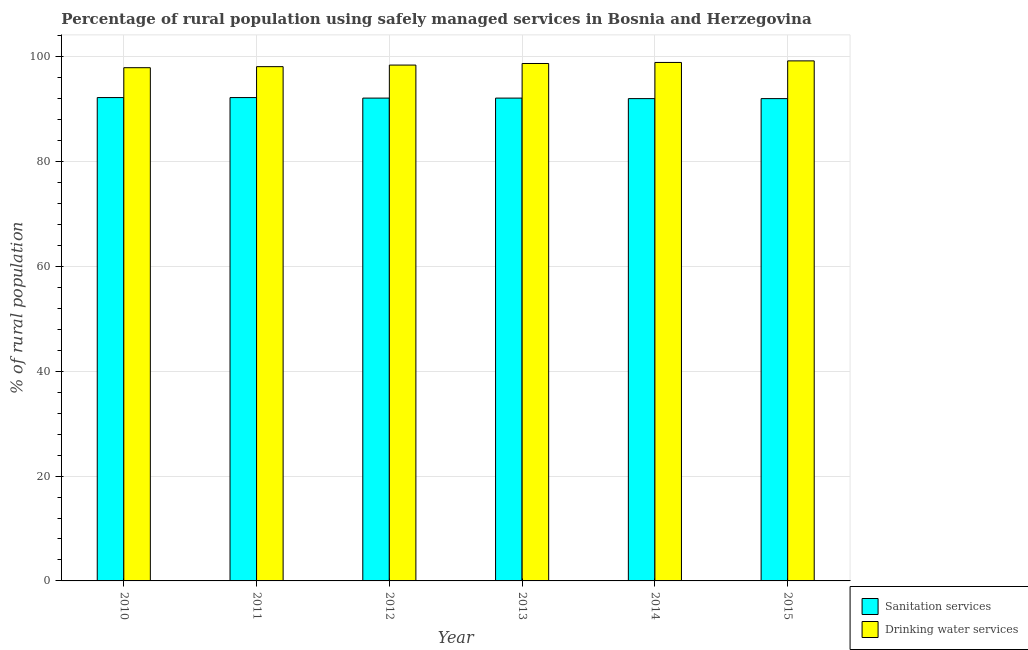How many different coloured bars are there?
Offer a very short reply. 2. How many groups of bars are there?
Offer a very short reply. 6. Are the number of bars per tick equal to the number of legend labels?
Ensure brevity in your answer.  Yes. Are the number of bars on each tick of the X-axis equal?
Your answer should be compact. Yes. How many bars are there on the 5th tick from the left?
Offer a very short reply. 2. How many bars are there on the 2nd tick from the right?
Keep it short and to the point. 2. What is the label of the 5th group of bars from the left?
Provide a short and direct response. 2014. In how many cases, is the number of bars for a given year not equal to the number of legend labels?
Offer a terse response. 0. What is the percentage of rural population who used drinking water services in 2012?
Offer a terse response. 98.4. Across all years, what is the maximum percentage of rural population who used sanitation services?
Ensure brevity in your answer.  92.2. Across all years, what is the minimum percentage of rural population who used sanitation services?
Provide a succinct answer. 92. What is the total percentage of rural population who used sanitation services in the graph?
Give a very brief answer. 552.6. What is the difference between the percentage of rural population who used sanitation services in 2011 and that in 2015?
Offer a terse response. 0.2. What is the difference between the percentage of rural population who used drinking water services in 2012 and the percentage of rural population who used sanitation services in 2011?
Your answer should be compact. 0.3. What is the average percentage of rural population who used drinking water services per year?
Make the answer very short. 98.53. In the year 2014, what is the difference between the percentage of rural population who used sanitation services and percentage of rural population who used drinking water services?
Your answer should be compact. 0. In how many years, is the percentage of rural population who used sanitation services greater than 28 %?
Give a very brief answer. 6. What is the ratio of the percentage of rural population who used sanitation services in 2011 to that in 2013?
Provide a short and direct response. 1. Is the percentage of rural population who used sanitation services in 2012 less than that in 2013?
Your response must be concise. No. What is the difference between the highest and the second highest percentage of rural population who used drinking water services?
Offer a very short reply. 0.3. What is the difference between the highest and the lowest percentage of rural population who used sanitation services?
Keep it short and to the point. 0.2. What does the 2nd bar from the left in 2014 represents?
Your response must be concise. Drinking water services. What does the 2nd bar from the right in 2013 represents?
Your answer should be very brief. Sanitation services. How many bars are there?
Your response must be concise. 12. How many years are there in the graph?
Give a very brief answer. 6. What is the difference between two consecutive major ticks on the Y-axis?
Make the answer very short. 20. Are the values on the major ticks of Y-axis written in scientific E-notation?
Your response must be concise. No. Does the graph contain any zero values?
Make the answer very short. No. Where does the legend appear in the graph?
Ensure brevity in your answer.  Bottom right. How are the legend labels stacked?
Your answer should be compact. Vertical. What is the title of the graph?
Offer a very short reply. Percentage of rural population using safely managed services in Bosnia and Herzegovina. What is the label or title of the Y-axis?
Make the answer very short. % of rural population. What is the % of rural population of Sanitation services in 2010?
Give a very brief answer. 92.2. What is the % of rural population of Drinking water services in 2010?
Your response must be concise. 97.9. What is the % of rural population of Sanitation services in 2011?
Ensure brevity in your answer.  92.2. What is the % of rural population in Drinking water services in 2011?
Keep it short and to the point. 98.1. What is the % of rural population in Sanitation services in 2012?
Your answer should be compact. 92.1. What is the % of rural population of Drinking water services in 2012?
Offer a very short reply. 98.4. What is the % of rural population of Sanitation services in 2013?
Make the answer very short. 92.1. What is the % of rural population in Drinking water services in 2013?
Give a very brief answer. 98.7. What is the % of rural population of Sanitation services in 2014?
Your answer should be very brief. 92. What is the % of rural population of Drinking water services in 2014?
Your answer should be very brief. 98.9. What is the % of rural population in Sanitation services in 2015?
Offer a very short reply. 92. What is the % of rural population in Drinking water services in 2015?
Your response must be concise. 99.2. Across all years, what is the maximum % of rural population in Sanitation services?
Ensure brevity in your answer.  92.2. Across all years, what is the maximum % of rural population of Drinking water services?
Give a very brief answer. 99.2. Across all years, what is the minimum % of rural population in Sanitation services?
Your answer should be very brief. 92. Across all years, what is the minimum % of rural population of Drinking water services?
Provide a succinct answer. 97.9. What is the total % of rural population in Sanitation services in the graph?
Make the answer very short. 552.6. What is the total % of rural population in Drinking water services in the graph?
Offer a terse response. 591.2. What is the difference between the % of rural population of Sanitation services in 2010 and that in 2011?
Make the answer very short. 0. What is the difference between the % of rural population of Drinking water services in 2010 and that in 2011?
Keep it short and to the point. -0.2. What is the difference between the % of rural population in Sanitation services in 2010 and that in 2012?
Your answer should be very brief. 0.1. What is the difference between the % of rural population of Drinking water services in 2010 and that in 2014?
Offer a very short reply. -1. What is the difference between the % of rural population of Sanitation services in 2011 and that in 2013?
Your answer should be compact. 0.1. What is the difference between the % of rural population of Drinking water services in 2011 and that in 2013?
Ensure brevity in your answer.  -0.6. What is the difference between the % of rural population in Drinking water services in 2011 and that in 2014?
Your response must be concise. -0.8. What is the difference between the % of rural population in Sanitation services in 2012 and that in 2014?
Give a very brief answer. 0.1. What is the difference between the % of rural population of Drinking water services in 2012 and that in 2014?
Provide a short and direct response. -0.5. What is the difference between the % of rural population of Sanitation services in 2012 and that in 2015?
Provide a short and direct response. 0.1. What is the difference between the % of rural population in Drinking water services in 2013 and that in 2015?
Your answer should be very brief. -0.5. What is the difference between the % of rural population in Sanitation services in 2014 and that in 2015?
Your answer should be compact. 0. What is the difference between the % of rural population in Sanitation services in 2010 and the % of rural population in Drinking water services in 2011?
Provide a short and direct response. -5.9. What is the difference between the % of rural population in Sanitation services in 2010 and the % of rural population in Drinking water services in 2012?
Your answer should be very brief. -6.2. What is the difference between the % of rural population of Sanitation services in 2010 and the % of rural population of Drinking water services in 2013?
Give a very brief answer. -6.5. What is the difference between the % of rural population of Sanitation services in 2010 and the % of rural population of Drinking water services in 2014?
Your response must be concise. -6.7. What is the difference between the % of rural population in Sanitation services in 2011 and the % of rural population in Drinking water services in 2015?
Offer a terse response. -7. What is the difference between the % of rural population of Sanitation services in 2012 and the % of rural population of Drinking water services in 2015?
Give a very brief answer. -7.1. What is the difference between the % of rural population of Sanitation services in 2013 and the % of rural population of Drinking water services in 2014?
Provide a short and direct response. -6.8. What is the difference between the % of rural population in Sanitation services in 2013 and the % of rural population in Drinking water services in 2015?
Make the answer very short. -7.1. What is the average % of rural population in Sanitation services per year?
Your answer should be very brief. 92.1. What is the average % of rural population of Drinking water services per year?
Give a very brief answer. 98.53. In the year 2013, what is the difference between the % of rural population of Sanitation services and % of rural population of Drinking water services?
Your response must be concise. -6.6. In the year 2014, what is the difference between the % of rural population in Sanitation services and % of rural population in Drinking water services?
Provide a short and direct response. -6.9. In the year 2015, what is the difference between the % of rural population of Sanitation services and % of rural population of Drinking water services?
Provide a succinct answer. -7.2. What is the ratio of the % of rural population of Sanitation services in 2010 to that in 2011?
Your answer should be compact. 1. What is the ratio of the % of rural population in Drinking water services in 2010 to that in 2011?
Your answer should be compact. 1. What is the ratio of the % of rural population in Drinking water services in 2010 to that in 2013?
Make the answer very short. 0.99. What is the ratio of the % of rural population in Sanitation services in 2010 to that in 2014?
Keep it short and to the point. 1. What is the ratio of the % of rural population in Sanitation services in 2010 to that in 2015?
Your answer should be very brief. 1. What is the ratio of the % of rural population of Drinking water services in 2010 to that in 2015?
Offer a very short reply. 0.99. What is the ratio of the % of rural population in Drinking water services in 2011 to that in 2013?
Offer a terse response. 0.99. What is the ratio of the % of rural population in Sanitation services in 2011 to that in 2014?
Give a very brief answer. 1. What is the ratio of the % of rural population of Drinking water services in 2011 to that in 2014?
Make the answer very short. 0.99. What is the ratio of the % of rural population of Sanitation services in 2011 to that in 2015?
Your answer should be compact. 1. What is the ratio of the % of rural population in Drinking water services in 2011 to that in 2015?
Keep it short and to the point. 0.99. What is the ratio of the % of rural population in Sanitation services in 2012 to that in 2013?
Your answer should be very brief. 1. What is the ratio of the % of rural population in Drinking water services in 2012 to that in 2013?
Make the answer very short. 1. What is the ratio of the % of rural population of Sanitation services in 2012 to that in 2014?
Provide a short and direct response. 1. What is the ratio of the % of rural population of Sanitation services in 2013 to that in 2014?
Provide a short and direct response. 1. What is the ratio of the % of rural population of Sanitation services in 2014 to that in 2015?
Ensure brevity in your answer.  1. What is the difference between the highest and the second highest % of rural population of Drinking water services?
Your response must be concise. 0.3. What is the difference between the highest and the lowest % of rural population of Sanitation services?
Ensure brevity in your answer.  0.2. What is the difference between the highest and the lowest % of rural population in Drinking water services?
Make the answer very short. 1.3. 